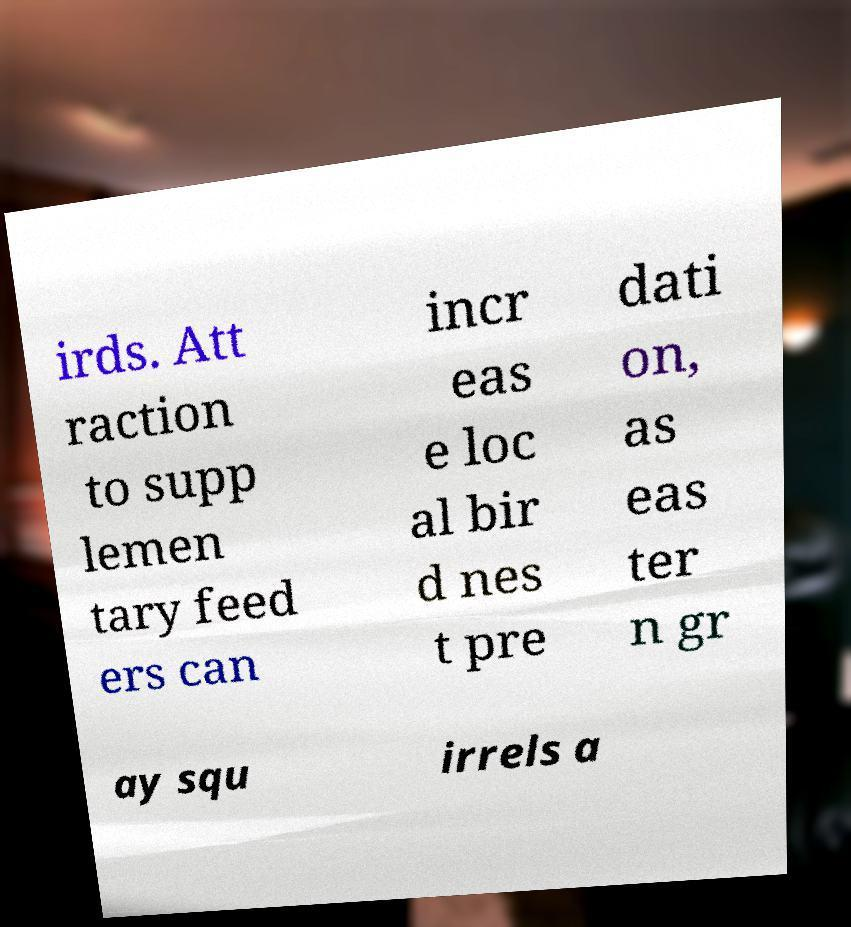There's text embedded in this image that I need extracted. Can you transcribe it verbatim? irds. Att raction to supp lemen tary feed ers can incr eas e loc al bir d nes t pre dati on, as eas ter n gr ay squ irrels a 